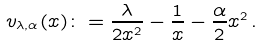Convert formula to latex. <formula><loc_0><loc_0><loc_500><loc_500>v _ { \lambda , \alpha } ( x ) \colon = \frac { \lambda } { 2 x ^ { 2 } } - \frac { 1 } { x } - \frac { \alpha } { 2 } x ^ { 2 } \, .</formula> 